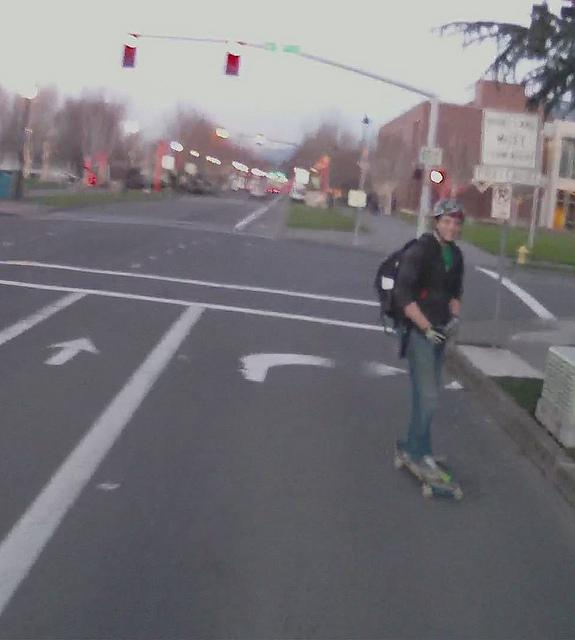A car turning which way is a hazard to this man? Please explain your reasoning. right. A man is skateboarding in the right turn lane of a road. 